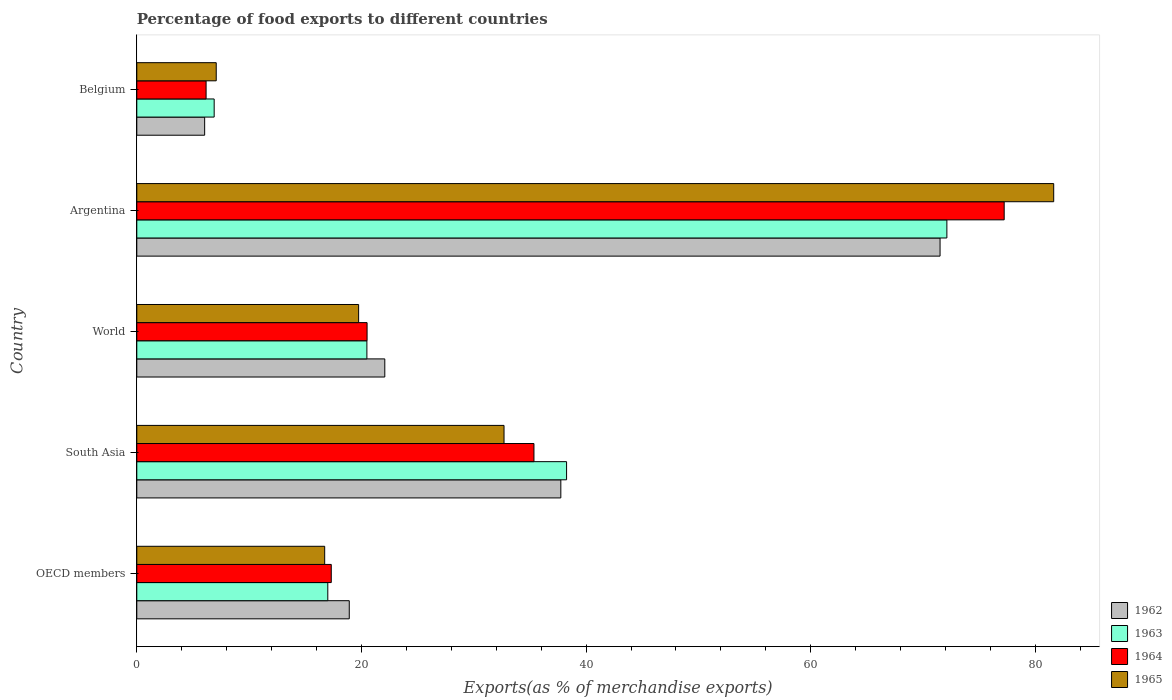How many different coloured bars are there?
Make the answer very short. 4. How many groups of bars are there?
Make the answer very short. 5. Are the number of bars per tick equal to the number of legend labels?
Provide a succinct answer. Yes. What is the percentage of exports to different countries in 1964 in Argentina?
Offer a very short reply. 77.23. Across all countries, what is the maximum percentage of exports to different countries in 1964?
Ensure brevity in your answer.  77.23. Across all countries, what is the minimum percentage of exports to different countries in 1965?
Offer a terse response. 7.07. In which country was the percentage of exports to different countries in 1964 minimum?
Your response must be concise. Belgium. What is the total percentage of exports to different countries in 1962 in the graph?
Your answer should be very brief. 156.31. What is the difference between the percentage of exports to different countries in 1964 in Argentina and that in World?
Your answer should be very brief. 56.72. What is the difference between the percentage of exports to different countries in 1965 in South Asia and the percentage of exports to different countries in 1963 in Belgium?
Your response must be concise. 25.81. What is the average percentage of exports to different countries in 1965 per country?
Keep it short and to the point. 31.58. What is the difference between the percentage of exports to different countries in 1963 and percentage of exports to different countries in 1964 in Belgium?
Give a very brief answer. 0.72. In how many countries, is the percentage of exports to different countries in 1964 greater than 52 %?
Offer a very short reply. 1. What is the ratio of the percentage of exports to different countries in 1964 in OECD members to that in South Asia?
Provide a succinct answer. 0.49. Is the percentage of exports to different countries in 1962 in Argentina less than that in Belgium?
Offer a very short reply. No. What is the difference between the highest and the second highest percentage of exports to different countries in 1964?
Offer a very short reply. 41.87. What is the difference between the highest and the lowest percentage of exports to different countries in 1962?
Provide a short and direct response. 65.47. Is the sum of the percentage of exports to different countries in 1964 in Belgium and South Asia greater than the maximum percentage of exports to different countries in 1965 across all countries?
Your response must be concise. No. What does the 1st bar from the top in Argentina represents?
Make the answer very short. 1965. What does the 3rd bar from the bottom in South Asia represents?
Ensure brevity in your answer.  1964. Are all the bars in the graph horizontal?
Your answer should be compact. Yes. What is the difference between two consecutive major ticks on the X-axis?
Provide a short and direct response. 20. What is the title of the graph?
Ensure brevity in your answer.  Percentage of food exports to different countries. Does "1966" appear as one of the legend labels in the graph?
Offer a very short reply. No. What is the label or title of the X-axis?
Make the answer very short. Exports(as % of merchandise exports). What is the label or title of the Y-axis?
Make the answer very short. Country. What is the Exports(as % of merchandise exports) of 1962 in OECD members?
Ensure brevity in your answer.  18.92. What is the Exports(as % of merchandise exports) of 1963 in OECD members?
Your response must be concise. 17.01. What is the Exports(as % of merchandise exports) of 1964 in OECD members?
Your answer should be compact. 17.31. What is the Exports(as % of merchandise exports) in 1965 in OECD members?
Your answer should be very brief. 16.73. What is the Exports(as % of merchandise exports) in 1962 in South Asia?
Give a very brief answer. 37.75. What is the Exports(as % of merchandise exports) of 1963 in South Asia?
Ensure brevity in your answer.  38.26. What is the Exports(as % of merchandise exports) in 1964 in South Asia?
Provide a succinct answer. 35.36. What is the Exports(as % of merchandise exports) of 1965 in South Asia?
Give a very brief answer. 32.7. What is the Exports(as % of merchandise exports) in 1962 in World?
Give a very brief answer. 22.08. What is the Exports(as % of merchandise exports) of 1963 in World?
Your answer should be compact. 20.49. What is the Exports(as % of merchandise exports) in 1964 in World?
Your answer should be compact. 20.5. What is the Exports(as % of merchandise exports) in 1965 in World?
Provide a succinct answer. 19.75. What is the Exports(as % of merchandise exports) of 1962 in Argentina?
Give a very brief answer. 71.52. What is the Exports(as % of merchandise exports) of 1963 in Argentina?
Your answer should be very brief. 72.12. What is the Exports(as % of merchandise exports) in 1964 in Argentina?
Give a very brief answer. 77.23. What is the Exports(as % of merchandise exports) in 1965 in Argentina?
Keep it short and to the point. 81.64. What is the Exports(as % of merchandise exports) in 1962 in Belgium?
Provide a short and direct response. 6.04. What is the Exports(as % of merchandise exports) of 1963 in Belgium?
Your response must be concise. 6.89. What is the Exports(as % of merchandise exports) of 1964 in Belgium?
Make the answer very short. 6.17. What is the Exports(as % of merchandise exports) in 1965 in Belgium?
Provide a succinct answer. 7.07. Across all countries, what is the maximum Exports(as % of merchandise exports) of 1962?
Make the answer very short. 71.52. Across all countries, what is the maximum Exports(as % of merchandise exports) of 1963?
Give a very brief answer. 72.12. Across all countries, what is the maximum Exports(as % of merchandise exports) of 1964?
Give a very brief answer. 77.23. Across all countries, what is the maximum Exports(as % of merchandise exports) of 1965?
Keep it short and to the point. 81.64. Across all countries, what is the minimum Exports(as % of merchandise exports) in 1962?
Keep it short and to the point. 6.04. Across all countries, what is the minimum Exports(as % of merchandise exports) of 1963?
Ensure brevity in your answer.  6.89. Across all countries, what is the minimum Exports(as % of merchandise exports) in 1964?
Offer a terse response. 6.17. Across all countries, what is the minimum Exports(as % of merchandise exports) in 1965?
Ensure brevity in your answer.  7.07. What is the total Exports(as % of merchandise exports) of 1962 in the graph?
Provide a short and direct response. 156.31. What is the total Exports(as % of merchandise exports) in 1963 in the graph?
Your response must be concise. 154.77. What is the total Exports(as % of merchandise exports) in 1964 in the graph?
Your answer should be compact. 156.57. What is the total Exports(as % of merchandise exports) of 1965 in the graph?
Give a very brief answer. 157.88. What is the difference between the Exports(as % of merchandise exports) in 1962 in OECD members and that in South Asia?
Provide a short and direct response. -18.84. What is the difference between the Exports(as % of merchandise exports) in 1963 in OECD members and that in South Asia?
Your answer should be compact. -21.26. What is the difference between the Exports(as % of merchandise exports) of 1964 in OECD members and that in South Asia?
Keep it short and to the point. -18.05. What is the difference between the Exports(as % of merchandise exports) of 1965 in OECD members and that in South Asia?
Keep it short and to the point. -15.97. What is the difference between the Exports(as % of merchandise exports) of 1962 in OECD members and that in World?
Keep it short and to the point. -3.16. What is the difference between the Exports(as % of merchandise exports) in 1963 in OECD members and that in World?
Your answer should be very brief. -3.48. What is the difference between the Exports(as % of merchandise exports) in 1964 in OECD members and that in World?
Your response must be concise. -3.19. What is the difference between the Exports(as % of merchandise exports) in 1965 in OECD members and that in World?
Ensure brevity in your answer.  -3.02. What is the difference between the Exports(as % of merchandise exports) in 1962 in OECD members and that in Argentina?
Keep it short and to the point. -52.6. What is the difference between the Exports(as % of merchandise exports) of 1963 in OECD members and that in Argentina?
Offer a very short reply. -55.12. What is the difference between the Exports(as % of merchandise exports) of 1964 in OECD members and that in Argentina?
Provide a short and direct response. -59.91. What is the difference between the Exports(as % of merchandise exports) of 1965 in OECD members and that in Argentina?
Provide a succinct answer. -64.91. What is the difference between the Exports(as % of merchandise exports) of 1962 in OECD members and that in Belgium?
Offer a terse response. 12.87. What is the difference between the Exports(as % of merchandise exports) in 1963 in OECD members and that in Belgium?
Offer a very short reply. 10.12. What is the difference between the Exports(as % of merchandise exports) in 1964 in OECD members and that in Belgium?
Your answer should be compact. 11.14. What is the difference between the Exports(as % of merchandise exports) of 1965 in OECD members and that in Belgium?
Give a very brief answer. 9.66. What is the difference between the Exports(as % of merchandise exports) in 1962 in South Asia and that in World?
Keep it short and to the point. 15.67. What is the difference between the Exports(as % of merchandise exports) of 1963 in South Asia and that in World?
Offer a terse response. 17.78. What is the difference between the Exports(as % of merchandise exports) in 1964 in South Asia and that in World?
Your response must be concise. 14.86. What is the difference between the Exports(as % of merchandise exports) in 1965 in South Asia and that in World?
Offer a terse response. 12.95. What is the difference between the Exports(as % of merchandise exports) of 1962 in South Asia and that in Argentina?
Keep it short and to the point. -33.76. What is the difference between the Exports(as % of merchandise exports) in 1963 in South Asia and that in Argentina?
Your answer should be compact. -33.86. What is the difference between the Exports(as % of merchandise exports) of 1964 in South Asia and that in Argentina?
Your answer should be very brief. -41.87. What is the difference between the Exports(as % of merchandise exports) of 1965 in South Asia and that in Argentina?
Your response must be concise. -48.94. What is the difference between the Exports(as % of merchandise exports) in 1962 in South Asia and that in Belgium?
Make the answer very short. 31.71. What is the difference between the Exports(as % of merchandise exports) of 1963 in South Asia and that in Belgium?
Keep it short and to the point. 31.37. What is the difference between the Exports(as % of merchandise exports) of 1964 in South Asia and that in Belgium?
Provide a short and direct response. 29.19. What is the difference between the Exports(as % of merchandise exports) in 1965 in South Asia and that in Belgium?
Ensure brevity in your answer.  25.62. What is the difference between the Exports(as % of merchandise exports) in 1962 in World and that in Argentina?
Offer a very short reply. -49.44. What is the difference between the Exports(as % of merchandise exports) of 1963 in World and that in Argentina?
Ensure brevity in your answer.  -51.64. What is the difference between the Exports(as % of merchandise exports) in 1964 in World and that in Argentina?
Offer a very short reply. -56.72. What is the difference between the Exports(as % of merchandise exports) in 1965 in World and that in Argentina?
Offer a very short reply. -61.88. What is the difference between the Exports(as % of merchandise exports) in 1962 in World and that in Belgium?
Provide a succinct answer. 16.04. What is the difference between the Exports(as % of merchandise exports) of 1963 in World and that in Belgium?
Provide a succinct answer. 13.6. What is the difference between the Exports(as % of merchandise exports) in 1964 in World and that in Belgium?
Your answer should be compact. 14.33. What is the difference between the Exports(as % of merchandise exports) in 1965 in World and that in Belgium?
Your answer should be very brief. 12.68. What is the difference between the Exports(as % of merchandise exports) of 1962 in Argentina and that in Belgium?
Your answer should be compact. 65.47. What is the difference between the Exports(as % of merchandise exports) of 1963 in Argentina and that in Belgium?
Provide a succinct answer. 65.23. What is the difference between the Exports(as % of merchandise exports) in 1964 in Argentina and that in Belgium?
Offer a very short reply. 71.06. What is the difference between the Exports(as % of merchandise exports) in 1965 in Argentina and that in Belgium?
Provide a short and direct response. 74.56. What is the difference between the Exports(as % of merchandise exports) in 1962 in OECD members and the Exports(as % of merchandise exports) in 1963 in South Asia?
Offer a very short reply. -19.35. What is the difference between the Exports(as % of merchandise exports) in 1962 in OECD members and the Exports(as % of merchandise exports) in 1964 in South Asia?
Make the answer very short. -16.44. What is the difference between the Exports(as % of merchandise exports) of 1962 in OECD members and the Exports(as % of merchandise exports) of 1965 in South Asia?
Offer a very short reply. -13.78. What is the difference between the Exports(as % of merchandise exports) of 1963 in OECD members and the Exports(as % of merchandise exports) of 1964 in South Asia?
Offer a very short reply. -18.35. What is the difference between the Exports(as % of merchandise exports) in 1963 in OECD members and the Exports(as % of merchandise exports) in 1965 in South Asia?
Your answer should be very brief. -15.69. What is the difference between the Exports(as % of merchandise exports) of 1964 in OECD members and the Exports(as % of merchandise exports) of 1965 in South Asia?
Provide a short and direct response. -15.38. What is the difference between the Exports(as % of merchandise exports) of 1962 in OECD members and the Exports(as % of merchandise exports) of 1963 in World?
Offer a terse response. -1.57. What is the difference between the Exports(as % of merchandise exports) in 1962 in OECD members and the Exports(as % of merchandise exports) in 1964 in World?
Your answer should be very brief. -1.59. What is the difference between the Exports(as % of merchandise exports) in 1962 in OECD members and the Exports(as % of merchandise exports) in 1965 in World?
Offer a very short reply. -0.83. What is the difference between the Exports(as % of merchandise exports) of 1963 in OECD members and the Exports(as % of merchandise exports) of 1964 in World?
Give a very brief answer. -3.5. What is the difference between the Exports(as % of merchandise exports) of 1963 in OECD members and the Exports(as % of merchandise exports) of 1965 in World?
Your answer should be compact. -2.74. What is the difference between the Exports(as % of merchandise exports) in 1964 in OECD members and the Exports(as % of merchandise exports) in 1965 in World?
Provide a succinct answer. -2.44. What is the difference between the Exports(as % of merchandise exports) in 1962 in OECD members and the Exports(as % of merchandise exports) in 1963 in Argentina?
Offer a very short reply. -53.21. What is the difference between the Exports(as % of merchandise exports) of 1962 in OECD members and the Exports(as % of merchandise exports) of 1964 in Argentina?
Ensure brevity in your answer.  -58.31. What is the difference between the Exports(as % of merchandise exports) of 1962 in OECD members and the Exports(as % of merchandise exports) of 1965 in Argentina?
Ensure brevity in your answer.  -62.72. What is the difference between the Exports(as % of merchandise exports) of 1963 in OECD members and the Exports(as % of merchandise exports) of 1964 in Argentina?
Provide a short and direct response. -60.22. What is the difference between the Exports(as % of merchandise exports) of 1963 in OECD members and the Exports(as % of merchandise exports) of 1965 in Argentina?
Your response must be concise. -64.63. What is the difference between the Exports(as % of merchandise exports) of 1964 in OECD members and the Exports(as % of merchandise exports) of 1965 in Argentina?
Provide a succinct answer. -64.32. What is the difference between the Exports(as % of merchandise exports) of 1962 in OECD members and the Exports(as % of merchandise exports) of 1963 in Belgium?
Keep it short and to the point. 12.03. What is the difference between the Exports(as % of merchandise exports) of 1962 in OECD members and the Exports(as % of merchandise exports) of 1964 in Belgium?
Keep it short and to the point. 12.75. What is the difference between the Exports(as % of merchandise exports) of 1962 in OECD members and the Exports(as % of merchandise exports) of 1965 in Belgium?
Provide a succinct answer. 11.84. What is the difference between the Exports(as % of merchandise exports) in 1963 in OECD members and the Exports(as % of merchandise exports) in 1964 in Belgium?
Give a very brief answer. 10.84. What is the difference between the Exports(as % of merchandise exports) of 1963 in OECD members and the Exports(as % of merchandise exports) of 1965 in Belgium?
Give a very brief answer. 9.93. What is the difference between the Exports(as % of merchandise exports) in 1964 in OECD members and the Exports(as % of merchandise exports) in 1965 in Belgium?
Make the answer very short. 10.24. What is the difference between the Exports(as % of merchandise exports) of 1962 in South Asia and the Exports(as % of merchandise exports) of 1963 in World?
Provide a short and direct response. 17.27. What is the difference between the Exports(as % of merchandise exports) of 1962 in South Asia and the Exports(as % of merchandise exports) of 1964 in World?
Make the answer very short. 17.25. What is the difference between the Exports(as % of merchandise exports) of 1962 in South Asia and the Exports(as % of merchandise exports) of 1965 in World?
Keep it short and to the point. 18. What is the difference between the Exports(as % of merchandise exports) of 1963 in South Asia and the Exports(as % of merchandise exports) of 1964 in World?
Offer a terse response. 17.76. What is the difference between the Exports(as % of merchandise exports) in 1963 in South Asia and the Exports(as % of merchandise exports) in 1965 in World?
Provide a succinct answer. 18.51. What is the difference between the Exports(as % of merchandise exports) of 1964 in South Asia and the Exports(as % of merchandise exports) of 1965 in World?
Your answer should be compact. 15.61. What is the difference between the Exports(as % of merchandise exports) of 1962 in South Asia and the Exports(as % of merchandise exports) of 1963 in Argentina?
Provide a short and direct response. -34.37. What is the difference between the Exports(as % of merchandise exports) of 1962 in South Asia and the Exports(as % of merchandise exports) of 1964 in Argentina?
Make the answer very short. -39.47. What is the difference between the Exports(as % of merchandise exports) in 1962 in South Asia and the Exports(as % of merchandise exports) in 1965 in Argentina?
Give a very brief answer. -43.88. What is the difference between the Exports(as % of merchandise exports) of 1963 in South Asia and the Exports(as % of merchandise exports) of 1964 in Argentina?
Offer a terse response. -38.96. What is the difference between the Exports(as % of merchandise exports) in 1963 in South Asia and the Exports(as % of merchandise exports) in 1965 in Argentina?
Keep it short and to the point. -43.37. What is the difference between the Exports(as % of merchandise exports) of 1964 in South Asia and the Exports(as % of merchandise exports) of 1965 in Argentina?
Your answer should be compact. -46.28. What is the difference between the Exports(as % of merchandise exports) of 1962 in South Asia and the Exports(as % of merchandise exports) of 1963 in Belgium?
Give a very brief answer. 30.86. What is the difference between the Exports(as % of merchandise exports) in 1962 in South Asia and the Exports(as % of merchandise exports) in 1964 in Belgium?
Ensure brevity in your answer.  31.58. What is the difference between the Exports(as % of merchandise exports) of 1962 in South Asia and the Exports(as % of merchandise exports) of 1965 in Belgium?
Make the answer very short. 30.68. What is the difference between the Exports(as % of merchandise exports) of 1963 in South Asia and the Exports(as % of merchandise exports) of 1964 in Belgium?
Ensure brevity in your answer.  32.09. What is the difference between the Exports(as % of merchandise exports) in 1963 in South Asia and the Exports(as % of merchandise exports) in 1965 in Belgium?
Your answer should be compact. 31.19. What is the difference between the Exports(as % of merchandise exports) in 1964 in South Asia and the Exports(as % of merchandise exports) in 1965 in Belgium?
Ensure brevity in your answer.  28.29. What is the difference between the Exports(as % of merchandise exports) in 1962 in World and the Exports(as % of merchandise exports) in 1963 in Argentina?
Provide a short and direct response. -50.04. What is the difference between the Exports(as % of merchandise exports) in 1962 in World and the Exports(as % of merchandise exports) in 1964 in Argentina?
Ensure brevity in your answer.  -55.15. What is the difference between the Exports(as % of merchandise exports) in 1962 in World and the Exports(as % of merchandise exports) in 1965 in Argentina?
Offer a terse response. -59.55. What is the difference between the Exports(as % of merchandise exports) in 1963 in World and the Exports(as % of merchandise exports) in 1964 in Argentina?
Provide a succinct answer. -56.74. What is the difference between the Exports(as % of merchandise exports) in 1963 in World and the Exports(as % of merchandise exports) in 1965 in Argentina?
Offer a terse response. -61.15. What is the difference between the Exports(as % of merchandise exports) of 1964 in World and the Exports(as % of merchandise exports) of 1965 in Argentina?
Your response must be concise. -61.13. What is the difference between the Exports(as % of merchandise exports) in 1962 in World and the Exports(as % of merchandise exports) in 1963 in Belgium?
Ensure brevity in your answer.  15.19. What is the difference between the Exports(as % of merchandise exports) of 1962 in World and the Exports(as % of merchandise exports) of 1964 in Belgium?
Offer a terse response. 15.91. What is the difference between the Exports(as % of merchandise exports) in 1962 in World and the Exports(as % of merchandise exports) in 1965 in Belgium?
Your answer should be very brief. 15.01. What is the difference between the Exports(as % of merchandise exports) in 1963 in World and the Exports(as % of merchandise exports) in 1964 in Belgium?
Provide a short and direct response. 14.32. What is the difference between the Exports(as % of merchandise exports) in 1963 in World and the Exports(as % of merchandise exports) in 1965 in Belgium?
Keep it short and to the point. 13.41. What is the difference between the Exports(as % of merchandise exports) of 1964 in World and the Exports(as % of merchandise exports) of 1965 in Belgium?
Ensure brevity in your answer.  13.43. What is the difference between the Exports(as % of merchandise exports) of 1962 in Argentina and the Exports(as % of merchandise exports) of 1963 in Belgium?
Ensure brevity in your answer.  64.63. What is the difference between the Exports(as % of merchandise exports) of 1962 in Argentina and the Exports(as % of merchandise exports) of 1964 in Belgium?
Provide a succinct answer. 65.35. What is the difference between the Exports(as % of merchandise exports) in 1962 in Argentina and the Exports(as % of merchandise exports) in 1965 in Belgium?
Give a very brief answer. 64.44. What is the difference between the Exports(as % of merchandise exports) of 1963 in Argentina and the Exports(as % of merchandise exports) of 1964 in Belgium?
Your answer should be very brief. 65.95. What is the difference between the Exports(as % of merchandise exports) of 1963 in Argentina and the Exports(as % of merchandise exports) of 1965 in Belgium?
Your answer should be compact. 65.05. What is the difference between the Exports(as % of merchandise exports) of 1964 in Argentina and the Exports(as % of merchandise exports) of 1965 in Belgium?
Make the answer very short. 70.15. What is the average Exports(as % of merchandise exports) of 1962 per country?
Your answer should be very brief. 31.26. What is the average Exports(as % of merchandise exports) in 1963 per country?
Your response must be concise. 30.95. What is the average Exports(as % of merchandise exports) of 1964 per country?
Your answer should be compact. 31.31. What is the average Exports(as % of merchandise exports) of 1965 per country?
Provide a short and direct response. 31.58. What is the difference between the Exports(as % of merchandise exports) in 1962 and Exports(as % of merchandise exports) in 1963 in OECD members?
Provide a succinct answer. 1.91. What is the difference between the Exports(as % of merchandise exports) in 1962 and Exports(as % of merchandise exports) in 1964 in OECD members?
Your answer should be very brief. 1.6. What is the difference between the Exports(as % of merchandise exports) in 1962 and Exports(as % of merchandise exports) in 1965 in OECD members?
Offer a terse response. 2.19. What is the difference between the Exports(as % of merchandise exports) of 1963 and Exports(as % of merchandise exports) of 1964 in OECD members?
Your answer should be compact. -0.31. What is the difference between the Exports(as % of merchandise exports) in 1963 and Exports(as % of merchandise exports) in 1965 in OECD members?
Your response must be concise. 0.28. What is the difference between the Exports(as % of merchandise exports) of 1964 and Exports(as % of merchandise exports) of 1965 in OECD members?
Your answer should be compact. 0.59. What is the difference between the Exports(as % of merchandise exports) of 1962 and Exports(as % of merchandise exports) of 1963 in South Asia?
Offer a terse response. -0.51. What is the difference between the Exports(as % of merchandise exports) in 1962 and Exports(as % of merchandise exports) in 1964 in South Asia?
Offer a very short reply. 2.39. What is the difference between the Exports(as % of merchandise exports) of 1962 and Exports(as % of merchandise exports) of 1965 in South Asia?
Your response must be concise. 5.06. What is the difference between the Exports(as % of merchandise exports) in 1963 and Exports(as % of merchandise exports) in 1964 in South Asia?
Provide a succinct answer. 2.9. What is the difference between the Exports(as % of merchandise exports) in 1963 and Exports(as % of merchandise exports) in 1965 in South Asia?
Provide a succinct answer. 5.57. What is the difference between the Exports(as % of merchandise exports) of 1964 and Exports(as % of merchandise exports) of 1965 in South Asia?
Give a very brief answer. 2.66. What is the difference between the Exports(as % of merchandise exports) of 1962 and Exports(as % of merchandise exports) of 1963 in World?
Make the answer very short. 1.59. What is the difference between the Exports(as % of merchandise exports) in 1962 and Exports(as % of merchandise exports) in 1964 in World?
Make the answer very short. 1.58. What is the difference between the Exports(as % of merchandise exports) of 1962 and Exports(as % of merchandise exports) of 1965 in World?
Ensure brevity in your answer.  2.33. What is the difference between the Exports(as % of merchandise exports) of 1963 and Exports(as % of merchandise exports) of 1964 in World?
Give a very brief answer. -0.02. What is the difference between the Exports(as % of merchandise exports) of 1963 and Exports(as % of merchandise exports) of 1965 in World?
Your response must be concise. 0.74. What is the difference between the Exports(as % of merchandise exports) of 1964 and Exports(as % of merchandise exports) of 1965 in World?
Give a very brief answer. 0.75. What is the difference between the Exports(as % of merchandise exports) of 1962 and Exports(as % of merchandise exports) of 1963 in Argentina?
Ensure brevity in your answer.  -0.61. What is the difference between the Exports(as % of merchandise exports) in 1962 and Exports(as % of merchandise exports) in 1964 in Argentina?
Offer a very short reply. -5.71. What is the difference between the Exports(as % of merchandise exports) in 1962 and Exports(as % of merchandise exports) in 1965 in Argentina?
Your response must be concise. -10.12. What is the difference between the Exports(as % of merchandise exports) of 1963 and Exports(as % of merchandise exports) of 1964 in Argentina?
Your answer should be very brief. -5.1. What is the difference between the Exports(as % of merchandise exports) in 1963 and Exports(as % of merchandise exports) in 1965 in Argentina?
Give a very brief answer. -9.51. What is the difference between the Exports(as % of merchandise exports) in 1964 and Exports(as % of merchandise exports) in 1965 in Argentina?
Give a very brief answer. -4.41. What is the difference between the Exports(as % of merchandise exports) of 1962 and Exports(as % of merchandise exports) of 1963 in Belgium?
Provide a succinct answer. -0.85. What is the difference between the Exports(as % of merchandise exports) of 1962 and Exports(as % of merchandise exports) of 1964 in Belgium?
Provide a short and direct response. -0.13. What is the difference between the Exports(as % of merchandise exports) in 1962 and Exports(as % of merchandise exports) in 1965 in Belgium?
Ensure brevity in your answer.  -1.03. What is the difference between the Exports(as % of merchandise exports) of 1963 and Exports(as % of merchandise exports) of 1964 in Belgium?
Your answer should be very brief. 0.72. What is the difference between the Exports(as % of merchandise exports) of 1963 and Exports(as % of merchandise exports) of 1965 in Belgium?
Provide a succinct answer. -0.18. What is the difference between the Exports(as % of merchandise exports) in 1964 and Exports(as % of merchandise exports) in 1965 in Belgium?
Offer a terse response. -0.9. What is the ratio of the Exports(as % of merchandise exports) in 1962 in OECD members to that in South Asia?
Provide a short and direct response. 0.5. What is the ratio of the Exports(as % of merchandise exports) of 1963 in OECD members to that in South Asia?
Your answer should be very brief. 0.44. What is the ratio of the Exports(as % of merchandise exports) in 1964 in OECD members to that in South Asia?
Offer a very short reply. 0.49. What is the ratio of the Exports(as % of merchandise exports) of 1965 in OECD members to that in South Asia?
Provide a short and direct response. 0.51. What is the ratio of the Exports(as % of merchandise exports) of 1962 in OECD members to that in World?
Make the answer very short. 0.86. What is the ratio of the Exports(as % of merchandise exports) in 1963 in OECD members to that in World?
Provide a short and direct response. 0.83. What is the ratio of the Exports(as % of merchandise exports) in 1964 in OECD members to that in World?
Your answer should be compact. 0.84. What is the ratio of the Exports(as % of merchandise exports) of 1965 in OECD members to that in World?
Make the answer very short. 0.85. What is the ratio of the Exports(as % of merchandise exports) of 1962 in OECD members to that in Argentina?
Offer a very short reply. 0.26. What is the ratio of the Exports(as % of merchandise exports) of 1963 in OECD members to that in Argentina?
Make the answer very short. 0.24. What is the ratio of the Exports(as % of merchandise exports) of 1964 in OECD members to that in Argentina?
Provide a short and direct response. 0.22. What is the ratio of the Exports(as % of merchandise exports) of 1965 in OECD members to that in Argentina?
Your answer should be compact. 0.2. What is the ratio of the Exports(as % of merchandise exports) in 1962 in OECD members to that in Belgium?
Provide a short and direct response. 3.13. What is the ratio of the Exports(as % of merchandise exports) in 1963 in OECD members to that in Belgium?
Provide a succinct answer. 2.47. What is the ratio of the Exports(as % of merchandise exports) of 1964 in OECD members to that in Belgium?
Keep it short and to the point. 2.81. What is the ratio of the Exports(as % of merchandise exports) in 1965 in OECD members to that in Belgium?
Your response must be concise. 2.37. What is the ratio of the Exports(as % of merchandise exports) of 1962 in South Asia to that in World?
Make the answer very short. 1.71. What is the ratio of the Exports(as % of merchandise exports) in 1963 in South Asia to that in World?
Give a very brief answer. 1.87. What is the ratio of the Exports(as % of merchandise exports) of 1964 in South Asia to that in World?
Offer a very short reply. 1.72. What is the ratio of the Exports(as % of merchandise exports) in 1965 in South Asia to that in World?
Your answer should be compact. 1.66. What is the ratio of the Exports(as % of merchandise exports) of 1962 in South Asia to that in Argentina?
Your response must be concise. 0.53. What is the ratio of the Exports(as % of merchandise exports) in 1963 in South Asia to that in Argentina?
Keep it short and to the point. 0.53. What is the ratio of the Exports(as % of merchandise exports) in 1964 in South Asia to that in Argentina?
Your answer should be compact. 0.46. What is the ratio of the Exports(as % of merchandise exports) in 1965 in South Asia to that in Argentina?
Provide a short and direct response. 0.4. What is the ratio of the Exports(as % of merchandise exports) in 1962 in South Asia to that in Belgium?
Make the answer very short. 6.25. What is the ratio of the Exports(as % of merchandise exports) in 1963 in South Asia to that in Belgium?
Give a very brief answer. 5.55. What is the ratio of the Exports(as % of merchandise exports) in 1964 in South Asia to that in Belgium?
Offer a terse response. 5.73. What is the ratio of the Exports(as % of merchandise exports) of 1965 in South Asia to that in Belgium?
Provide a short and direct response. 4.62. What is the ratio of the Exports(as % of merchandise exports) of 1962 in World to that in Argentina?
Your answer should be compact. 0.31. What is the ratio of the Exports(as % of merchandise exports) in 1963 in World to that in Argentina?
Ensure brevity in your answer.  0.28. What is the ratio of the Exports(as % of merchandise exports) of 1964 in World to that in Argentina?
Provide a short and direct response. 0.27. What is the ratio of the Exports(as % of merchandise exports) of 1965 in World to that in Argentina?
Offer a very short reply. 0.24. What is the ratio of the Exports(as % of merchandise exports) in 1962 in World to that in Belgium?
Keep it short and to the point. 3.65. What is the ratio of the Exports(as % of merchandise exports) of 1963 in World to that in Belgium?
Offer a terse response. 2.97. What is the ratio of the Exports(as % of merchandise exports) in 1964 in World to that in Belgium?
Give a very brief answer. 3.32. What is the ratio of the Exports(as % of merchandise exports) in 1965 in World to that in Belgium?
Make the answer very short. 2.79. What is the ratio of the Exports(as % of merchandise exports) in 1962 in Argentina to that in Belgium?
Provide a succinct answer. 11.84. What is the ratio of the Exports(as % of merchandise exports) in 1963 in Argentina to that in Belgium?
Give a very brief answer. 10.47. What is the ratio of the Exports(as % of merchandise exports) in 1964 in Argentina to that in Belgium?
Your answer should be very brief. 12.52. What is the ratio of the Exports(as % of merchandise exports) in 1965 in Argentina to that in Belgium?
Your response must be concise. 11.54. What is the difference between the highest and the second highest Exports(as % of merchandise exports) of 1962?
Your response must be concise. 33.76. What is the difference between the highest and the second highest Exports(as % of merchandise exports) in 1963?
Offer a terse response. 33.86. What is the difference between the highest and the second highest Exports(as % of merchandise exports) of 1964?
Ensure brevity in your answer.  41.87. What is the difference between the highest and the second highest Exports(as % of merchandise exports) of 1965?
Keep it short and to the point. 48.94. What is the difference between the highest and the lowest Exports(as % of merchandise exports) in 1962?
Your answer should be very brief. 65.47. What is the difference between the highest and the lowest Exports(as % of merchandise exports) in 1963?
Your answer should be very brief. 65.23. What is the difference between the highest and the lowest Exports(as % of merchandise exports) of 1964?
Provide a short and direct response. 71.06. What is the difference between the highest and the lowest Exports(as % of merchandise exports) of 1965?
Provide a short and direct response. 74.56. 